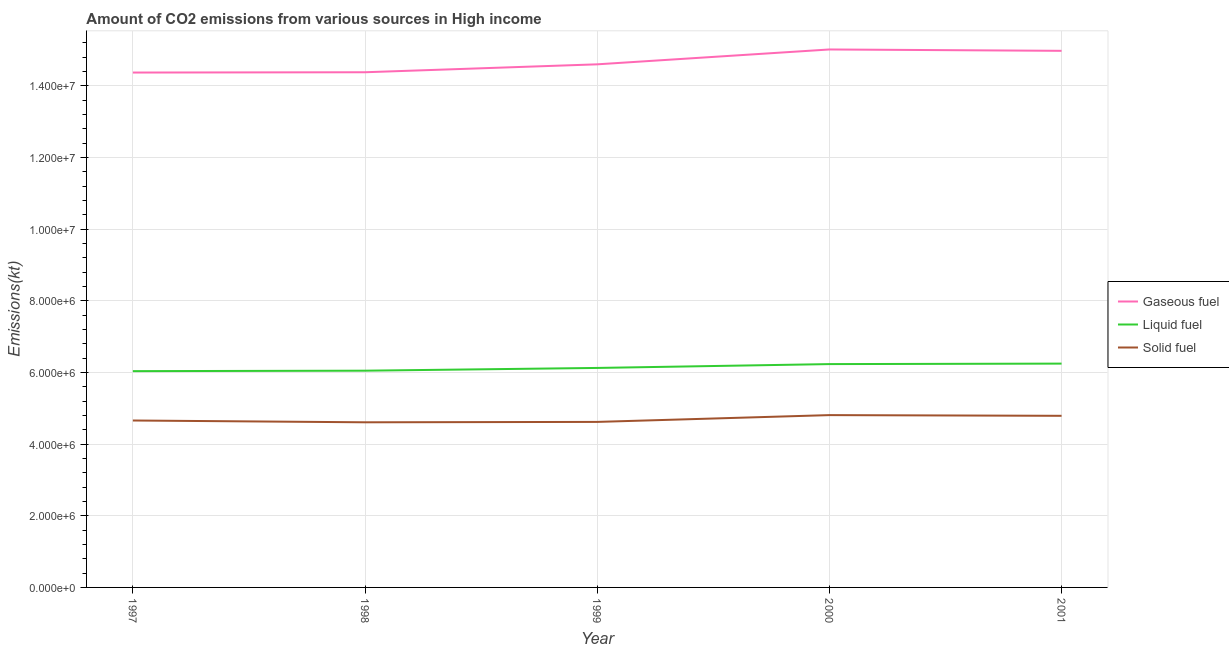What is the amount of co2 emissions from liquid fuel in 2000?
Provide a short and direct response. 6.23e+06. Across all years, what is the maximum amount of co2 emissions from solid fuel?
Offer a terse response. 4.81e+06. Across all years, what is the minimum amount of co2 emissions from liquid fuel?
Make the answer very short. 6.04e+06. What is the total amount of co2 emissions from gaseous fuel in the graph?
Ensure brevity in your answer.  7.33e+07. What is the difference between the amount of co2 emissions from liquid fuel in 2000 and that in 2001?
Your response must be concise. -1.36e+04. What is the difference between the amount of co2 emissions from gaseous fuel in 1999 and the amount of co2 emissions from solid fuel in 2000?
Make the answer very short. 9.79e+06. What is the average amount of co2 emissions from solid fuel per year?
Offer a terse response. 4.70e+06. In the year 2001, what is the difference between the amount of co2 emissions from gaseous fuel and amount of co2 emissions from solid fuel?
Provide a succinct answer. 1.02e+07. In how many years, is the amount of co2 emissions from gaseous fuel greater than 9600000 kt?
Your answer should be compact. 5. What is the ratio of the amount of co2 emissions from gaseous fuel in 1997 to that in 1999?
Offer a terse response. 0.98. Is the difference between the amount of co2 emissions from solid fuel in 1997 and 2001 greater than the difference between the amount of co2 emissions from gaseous fuel in 1997 and 2001?
Provide a short and direct response. Yes. What is the difference between the highest and the second highest amount of co2 emissions from solid fuel?
Your answer should be compact. 1.97e+04. What is the difference between the highest and the lowest amount of co2 emissions from gaseous fuel?
Provide a short and direct response. 6.44e+05. Is the sum of the amount of co2 emissions from gaseous fuel in 1997 and 2001 greater than the maximum amount of co2 emissions from liquid fuel across all years?
Give a very brief answer. Yes. Is it the case that in every year, the sum of the amount of co2 emissions from gaseous fuel and amount of co2 emissions from liquid fuel is greater than the amount of co2 emissions from solid fuel?
Your answer should be compact. Yes. Is the amount of co2 emissions from liquid fuel strictly greater than the amount of co2 emissions from solid fuel over the years?
Your response must be concise. Yes. How many lines are there?
Your answer should be very brief. 3. How many years are there in the graph?
Offer a very short reply. 5. What is the difference between two consecutive major ticks on the Y-axis?
Offer a very short reply. 2.00e+06. Does the graph contain grids?
Keep it short and to the point. Yes. Where does the legend appear in the graph?
Your answer should be very brief. Center right. What is the title of the graph?
Your response must be concise. Amount of CO2 emissions from various sources in High income. What is the label or title of the Y-axis?
Offer a terse response. Emissions(kt). What is the Emissions(kt) in Gaseous fuel in 1997?
Your response must be concise. 1.44e+07. What is the Emissions(kt) of Liquid fuel in 1997?
Offer a very short reply. 6.04e+06. What is the Emissions(kt) in Solid fuel in 1997?
Give a very brief answer. 4.66e+06. What is the Emissions(kt) of Gaseous fuel in 1998?
Provide a succinct answer. 1.44e+07. What is the Emissions(kt) of Liquid fuel in 1998?
Provide a short and direct response. 6.05e+06. What is the Emissions(kt) in Solid fuel in 1998?
Offer a very short reply. 4.61e+06. What is the Emissions(kt) in Gaseous fuel in 1999?
Offer a very short reply. 1.46e+07. What is the Emissions(kt) in Liquid fuel in 1999?
Give a very brief answer. 6.13e+06. What is the Emissions(kt) of Solid fuel in 1999?
Your answer should be compact. 4.62e+06. What is the Emissions(kt) of Gaseous fuel in 2000?
Your answer should be compact. 1.50e+07. What is the Emissions(kt) in Liquid fuel in 2000?
Keep it short and to the point. 6.23e+06. What is the Emissions(kt) in Solid fuel in 2000?
Offer a very short reply. 4.81e+06. What is the Emissions(kt) of Gaseous fuel in 2001?
Offer a very short reply. 1.50e+07. What is the Emissions(kt) of Liquid fuel in 2001?
Keep it short and to the point. 6.25e+06. What is the Emissions(kt) of Solid fuel in 2001?
Your response must be concise. 4.79e+06. Across all years, what is the maximum Emissions(kt) of Gaseous fuel?
Keep it short and to the point. 1.50e+07. Across all years, what is the maximum Emissions(kt) in Liquid fuel?
Keep it short and to the point. 6.25e+06. Across all years, what is the maximum Emissions(kt) in Solid fuel?
Offer a very short reply. 4.81e+06. Across all years, what is the minimum Emissions(kt) of Gaseous fuel?
Offer a terse response. 1.44e+07. Across all years, what is the minimum Emissions(kt) of Liquid fuel?
Your answer should be compact. 6.04e+06. Across all years, what is the minimum Emissions(kt) in Solid fuel?
Your response must be concise. 4.61e+06. What is the total Emissions(kt) of Gaseous fuel in the graph?
Offer a terse response. 7.33e+07. What is the total Emissions(kt) in Liquid fuel in the graph?
Provide a succinct answer. 3.07e+07. What is the total Emissions(kt) in Solid fuel in the graph?
Provide a short and direct response. 2.35e+07. What is the difference between the Emissions(kt) of Gaseous fuel in 1997 and that in 1998?
Offer a terse response. -8284.12. What is the difference between the Emissions(kt) of Liquid fuel in 1997 and that in 1998?
Your answer should be very brief. -1.28e+04. What is the difference between the Emissions(kt) of Solid fuel in 1997 and that in 1998?
Offer a terse response. 5.02e+04. What is the difference between the Emissions(kt) in Gaseous fuel in 1997 and that in 1999?
Make the answer very short. -2.29e+05. What is the difference between the Emissions(kt) of Liquid fuel in 1997 and that in 1999?
Your answer should be very brief. -8.96e+04. What is the difference between the Emissions(kt) in Solid fuel in 1997 and that in 1999?
Give a very brief answer. 3.94e+04. What is the difference between the Emissions(kt) in Gaseous fuel in 1997 and that in 2000?
Your response must be concise. -6.44e+05. What is the difference between the Emissions(kt) in Liquid fuel in 1997 and that in 2000?
Give a very brief answer. -1.97e+05. What is the difference between the Emissions(kt) in Solid fuel in 1997 and that in 2000?
Offer a terse response. -1.51e+05. What is the difference between the Emissions(kt) in Gaseous fuel in 1997 and that in 2001?
Make the answer very short. -6.06e+05. What is the difference between the Emissions(kt) of Liquid fuel in 1997 and that in 2001?
Provide a succinct answer. -2.10e+05. What is the difference between the Emissions(kt) of Solid fuel in 1997 and that in 2001?
Your answer should be compact. -1.31e+05. What is the difference between the Emissions(kt) in Gaseous fuel in 1998 and that in 1999?
Provide a succinct answer. -2.21e+05. What is the difference between the Emissions(kt) of Liquid fuel in 1998 and that in 1999?
Make the answer very short. -7.68e+04. What is the difference between the Emissions(kt) of Solid fuel in 1998 and that in 1999?
Keep it short and to the point. -1.08e+04. What is the difference between the Emissions(kt) in Gaseous fuel in 1998 and that in 2000?
Your answer should be compact. -6.36e+05. What is the difference between the Emissions(kt) in Liquid fuel in 1998 and that in 2000?
Make the answer very short. -1.84e+05. What is the difference between the Emissions(kt) in Solid fuel in 1998 and that in 2000?
Give a very brief answer. -2.01e+05. What is the difference between the Emissions(kt) in Gaseous fuel in 1998 and that in 2001?
Make the answer very short. -5.98e+05. What is the difference between the Emissions(kt) of Liquid fuel in 1998 and that in 2001?
Provide a short and direct response. -1.98e+05. What is the difference between the Emissions(kt) of Solid fuel in 1998 and that in 2001?
Provide a succinct answer. -1.81e+05. What is the difference between the Emissions(kt) in Gaseous fuel in 1999 and that in 2000?
Offer a terse response. -4.15e+05. What is the difference between the Emissions(kt) of Liquid fuel in 1999 and that in 2000?
Provide a succinct answer. -1.07e+05. What is the difference between the Emissions(kt) of Solid fuel in 1999 and that in 2000?
Give a very brief answer. -1.90e+05. What is the difference between the Emissions(kt) in Gaseous fuel in 1999 and that in 2001?
Keep it short and to the point. -3.77e+05. What is the difference between the Emissions(kt) in Liquid fuel in 1999 and that in 2001?
Ensure brevity in your answer.  -1.21e+05. What is the difference between the Emissions(kt) of Solid fuel in 1999 and that in 2001?
Offer a very short reply. -1.70e+05. What is the difference between the Emissions(kt) in Gaseous fuel in 2000 and that in 2001?
Your answer should be compact. 3.80e+04. What is the difference between the Emissions(kt) of Liquid fuel in 2000 and that in 2001?
Ensure brevity in your answer.  -1.36e+04. What is the difference between the Emissions(kt) of Solid fuel in 2000 and that in 2001?
Your answer should be very brief. 1.97e+04. What is the difference between the Emissions(kt) of Gaseous fuel in 1997 and the Emissions(kt) of Liquid fuel in 1998?
Give a very brief answer. 8.32e+06. What is the difference between the Emissions(kt) of Gaseous fuel in 1997 and the Emissions(kt) of Solid fuel in 1998?
Give a very brief answer. 9.76e+06. What is the difference between the Emissions(kt) of Liquid fuel in 1997 and the Emissions(kt) of Solid fuel in 1998?
Your answer should be compact. 1.43e+06. What is the difference between the Emissions(kt) in Gaseous fuel in 1997 and the Emissions(kt) in Liquid fuel in 1999?
Ensure brevity in your answer.  8.25e+06. What is the difference between the Emissions(kt) in Gaseous fuel in 1997 and the Emissions(kt) in Solid fuel in 1999?
Provide a succinct answer. 9.75e+06. What is the difference between the Emissions(kt) in Liquid fuel in 1997 and the Emissions(kt) in Solid fuel in 1999?
Provide a short and direct response. 1.42e+06. What is the difference between the Emissions(kt) in Gaseous fuel in 1997 and the Emissions(kt) in Liquid fuel in 2000?
Give a very brief answer. 8.14e+06. What is the difference between the Emissions(kt) of Gaseous fuel in 1997 and the Emissions(kt) of Solid fuel in 2000?
Your answer should be compact. 9.56e+06. What is the difference between the Emissions(kt) of Liquid fuel in 1997 and the Emissions(kt) of Solid fuel in 2000?
Offer a terse response. 1.23e+06. What is the difference between the Emissions(kt) in Gaseous fuel in 1997 and the Emissions(kt) in Liquid fuel in 2001?
Keep it short and to the point. 8.12e+06. What is the difference between the Emissions(kt) in Gaseous fuel in 1997 and the Emissions(kt) in Solid fuel in 2001?
Your response must be concise. 9.58e+06. What is the difference between the Emissions(kt) in Liquid fuel in 1997 and the Emissions(kt) in Solid fuel in 2001?
Provide a short and direct response. 1.25e+06. What is the difference between the Emissions(kt) of Gaseous fuel in 1998 and the Emissions(kt) of Liquid fuel in 1999?
Offer a very short reply. 8.25e+06. What is the difference between the Emissions(kt) in Gaseous fuel in 1998 and the Emissions(kt) in Solid fuel in 1999?
Give a very brief answer. 9.76e+06. What is the difference between the Emissions(kt) of Liquid fuel in 1998 and the Emissions(kt) of Solid fuel in 1999?
Ensure brevity in your answer.  1.43e+06. What is the difference between the Emissions(kt) of Gaseous fuel in 1998 and the Emissions(kt) of Liquid fuel in 2000?
Your response must be concise. 8.15e+06. What is the difference between the Emissions(kt) in Gaseous fuel in 1998 and the Emissions(kt) in Solid fuel in 2000?
Your response must be concise. 9.57e+06. What is the difference between the Emissions(kt) in Liquid fuel in 1998 and the Emissions(kt) in Solid fuel in 2000?
Your answer should be very brief. 1.24e+06. What is the difference between the Emissions(kt) of Gaseous fuel in 1998 and the Emissions(kt) of Liquid fuel in 2001?
Offer a very short reply. 8.13e+06. What is the difference between the Emissions(kt) of Gaseous fuel in 1998 and the Emissions(kt) of Solid fuel in 2001?
Ensure brevity in your answer.  9.59e+06. What is the difference between the Emissions(kt) in Liquid fuel in 1998 and the Emissions(kt) in Solid fuel in 2001?
Your response must be concise. 1.26e+06. What is the difference between the Emissions(kt) in Gaseous fuel in 1999 and the Emissions(kt) in Liquid fuel in 2000?
Ensure brevity in your answer.  8.37e+06. What is the difference between the Emissions(kt) in Gaseous fuel in 1999 and the Emissions(kt) in Solid fuel in 2000?
Give a very brief answer. 9.79e+06. What is the difference between the Emissions(kt) in Liquid fuel in 1999 and the Emissions(kt) in Solid fuel in 2000?
Your answer should be very brief. 1.32e+06. What is the difference between the Emissions(kt) of Gaseous fuel in 1999 and the Emissions(kt) of Liquid fuel in 2001?
Keep it short and to the point. 8.35e+06. What is the difference between the Emissions(kt) of Gaseous fuel in 1999 and the Emissions(kt) of Solid fuel in 2001?
Provide a succinct answer. 9.81e+06. What is the difference between the Emissions(kt) in Liquid fuel in 1999 and the Emissions(kt) in Solid fuel in 2001?
Provide a succinct answer. 1.34e+06. What is the difference between the Emissions(kt) in Gaseous fuel in 2000 and the Emissions(kt) in Liquid fuel in 2001?
Offer a very short reply. 8.77e+06. What is the difference between the Emissions(kt) of Gaseous fuel in 2000 and the Emissions(kt) of Solid fuel in 2001?
Your answer should be very brief. 1.02e+07. What is the difference between the Emissions(kt) in Liquid fuel in 2000 and the Emissions(kt) in Solid fuel in 2001?
Your answer should be compact. 1.44e+06. What is the average Emissions(kt) of Gaseous fuel per year?
Your answer should be very brief. 1.47e+07. What is the average Emissions(kt) of Liquid fuel per year?
Provide a succinct answer. 6.14e+06. What is the average Emissions(kt) of Solid fuel per year?
Make the answer very short. 4.70e+06. In the year 1997, what is the difference between the Emissions(kt) of Gaseous fuel and Emissions(kt) of Liquid fuel?
Your answer should be very brief. 8.33e+06. In the year 1997, what is the difference between the Emissions(kt) of Gaseous fuel and Emissions(kt) of Solid fuel?
Provide a succinct answer. 9.71e+06. In the year 1997, what is the difference between the Emissions(kt) of Liquid fuel and Emissions(kt) of Solid fuel?
Provide a short and direct response. 1.38e+06. In the year 1998, what is the difference between the Emissions(kt) of Gaseous fuel and Emissions(kt) of Liquid fuel?
Your response must be concise. 8.33e+06. In the year 1998, what is the difference between the Emissions(kt) in Gaseous fuel and Emissions(kt) in Solid fuel?
Your answer should be very brief. 9.77e+06. In the year 1998, what is the difference between the Emissions(kt) of Liquid fuel and Emissions(kt) of Solid fuel?
Offer a terse response. 1.44e+06. In the year 1999, what is the difference between the Emissions(kt) in Gaseous fuel and Emissions(kt) in Liquid fuel?
Offer a terse response. 8.47e+06. In the year 1999, what is the difference between the Emissions(kt) of Gaseous fuel and Emissions(kt) of Solid fuel?
Ensure brevity in your answer.  9.98e+06. In the year 1999, what is the difference between the Emissions(kt) in Liquid fuel and Emissions(kt) in Solid fuel?
Keep it short and to the point. 1.51e+06. In the year 2000, what is the difference between the Emissions(kt) in Gaseous fuel and Emissions(kt) in Liquid fuel?
Your answer should be compact. 8.78e+06. In the year 2000, what is the difference between the Emissions(kt) of Gaseous fuel and Emissions(kt) of Solid fuel?
Give a very brief answer. 1.02e+07. In the year 2000, what is the difference between the Emissions(kt) in Liquid fuel and Emissions(kt) in Solid fuel?
Your answer should be compact. 1.42e+06. In the year 2001, what is the difference between the Emissions(kt) of Gaseous fuel and Emissions(kt) of Liquid fuel?
Offer a very short reply. 8.73e+06. In the year 2001, what is the difference between the Emissions(kt) in Gaseous fuel and Emissions(kt) in Solid fuel?
Your answer should be compact. 1.02e+07. In the year 2001, what is the difference between the Emissions(kt) in Liquid fuel and Emissions(kt) in Solid fuel?
Ensure brevity in your answer.  1.46e+06. What is the ratio of the Emissions(kt) in Liquid fuel in 1997 to that in 1998?
Offer a very short reply. 1. What is the ratio of the Emissions(kt) of Solid fuel in 1997 to that in 1998?
Keep it short and to the point. 1.01. What is the ratio of the Emissions(kt) in Gaseous fuel in 1997 to that in 1999?
Provide a succinct answer. 0.98. What is the ratio of the Emissions(kt) of Liquid fuel in 1997 to that in 1999?
Provide a short and direct response. 0.99. What is the ratio of the Emissions(kt) in Solid fuel in 1997 to that in 1999?
Offer a terse response. 1.01. What is the ratio of the Emissions(kt) in Gaseous fuel in 1997 to that in 2000?
Offer a terse response. 0.96. What is the ratio of the Emissions(kt) in Liquid fuel in 1997 to that in 2000?
Make the answer very short. 0.97. What is the ratio of the Emissions(kt) in Solid fuel in 1997 to that in 2000?
Give a very brief answer. 0.97. What is the ratio of the Emissions(kt) of Gaseous fuel in 1997 to that in 2001?
Provide a short and direct response. 0.96. What is the ratio of the Emissions(kt) in Liquid fuel in 1997 to that in 2001?
Ensure brevity in your answer.  0.97. What is the ratio of the Emissions(kt) in Solid fuel in 1997 to that in 2001?
Give a very brief answer. 0.97. What is the ratio of the Emissions(kt) in Gaseous fuel in 1998 to that in 1999?
Ensure brevity in your answer.  0.98. What is the ratio of the Emissions(kt) of Liquid fuel in 1998 to that in 1999?
Ensure brevity in your answer.  0.99. What is the ratio of the Emissions(kt) of Solid fuel in 1998 to that in 1999?
Offer a very short reply. 1. What is the ratio of the Emissions(kt) of Gaseous fuel in 1998 to that in 2000?
Your answer should be compact. 0.96. What is the ratio of the Emissions(kt) of Liquid fuel in 1998 to that in 2000?
Your answer should be very brief. 0.97. What is the ratio of the Emissions(kt) in Gaseous fuel in 1998 to that in 2001?
Provide a short and direct response. 0.96. What is the ratio of the Emissions(kt) in Liquid fuel in 1998 to that in 2001?
Give a very brief answer. 0.97. What is the ratio of the Emissions(kt) in Solid fuel in 1998 to that in 2001?
Offer a terse response. 0.96. What is the ratio of the Emissions(kt) of Gaseous fuel in 1999 to that in 2000?
Provide a succinct answer. 0.97. What is the ratio of the Emissions(kt) in Liquid fuel in 1999 to that in 2000?
Offer a terse response. 0.98. What is the ratio of the Emissions(kt) of Solid fuel in 1999 to that in 2000?
Give a very brief answer. 0.96. What is the ratio of the Emissions(kt) in Gaseous fuel in 1999 to that in 2001?
Make the answer very short. 0.97. What is the ratio of the Emissions(kt) in Liquid fuel in 1999 to that in 2001?
Give a very brief answer. 0.98. What is the ratio of the Emissions(kt) of Solid fuel in 1999 to that in 2001?
Offer a terse response. 0.96. What is the ratio of the Emissions(kt) of Gaseous fuel in 2000 to that in 2001?
Your answer should be very brief. 1. What is the difference between the highest and the second highest Emissions(kt) of Gaseous fuel?
Make the answer very short. 3.80e+04. What is the difference between the highest and the second highest Emissions(kt) in Liquid fuel?
Your response must be concise. 1.36e+04. What is the difference between the highest and the second highest Emissions(kt) in Solid fuel?
Provide a short and direct response. 1.97e+04. What is the difference between the highest and the lowest Emissions(kt) of Gaseous fuel?
Provide a short and direct response. 6.44e+05. What is the difference between the highest and the lowest Emissions(kt) of Liquid fuel?
Provide a short and direct response. 2.10e+05. What is the difference between the highest and the lowest Emissions(kt) in Solid fuel?
Your response must be concise. 2.01e+05. 